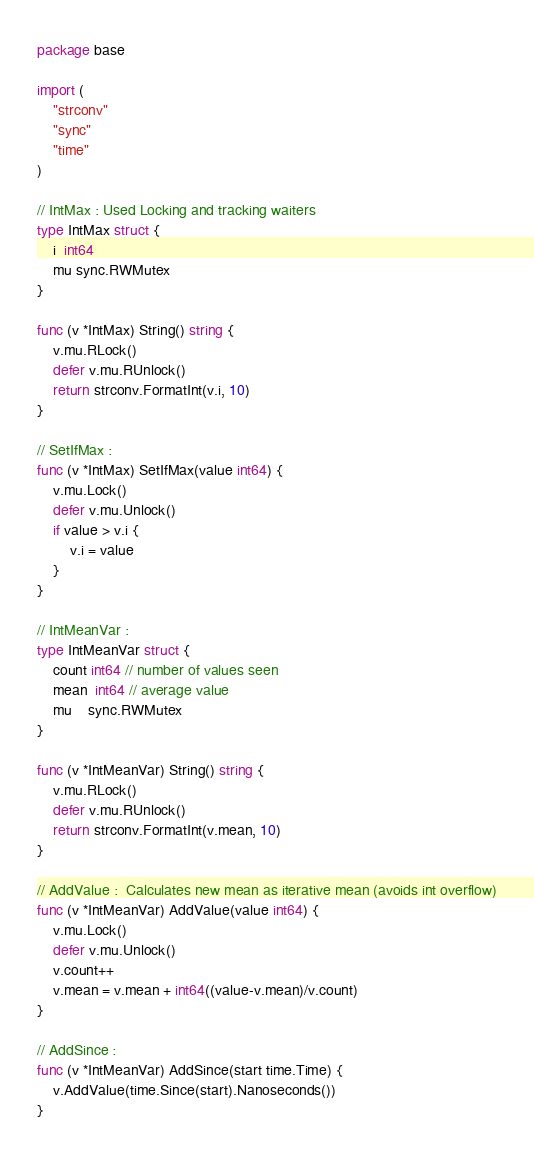Convert code to text. <code><loc_0><loc_0><loc_500><loc_500><_Go_>package base

import (
	"strconv"
	"sync"
	"time"
)

// IntMax : Used Locking and tracking waiters
type IntMax struct {
	i  int64
	mu sync.RWMutex
}

func (v *IntMax) String() string {
	v.mu.RLock()
	defer v.mu.RUnlock()
	return strconv.FormatInt(v.i, 10)
}

// SetIfMax :
func (v *IntMax) SetIfMax(value int64) {
	v.mu.Lock()
	defer v.mu.Unlock()
	if value > v.i {
		v.i = value
	}
}

// IntMeanVar :
type IntMeanVar struct {
	count int64 // number of values seen
	mean  int64 // average value
	mu    sync.RWMutex
}

func (v *IntMeanVar) String() string {
	v.mu.RLock()
	defer v.mu.RUnlock()
	return strconv.FormatInt(v.mean, 10)
}

// AddValue :  Calculates new mean as iterative mean (avoids int overflow)
func (v *IntMeanVar) AddValue(value int64) {
	v.mu.Lock()
	defer v.mu.Unlock()
	v.count++
	v.mean = v.mean + int64((value-v.mean)/v.count)
}

// AddSince :
func (v *IntMeanVar) AddSince(start time.Time) {
	v.AddValue(time.Since(start).Nanoseconds())
}
</code> 